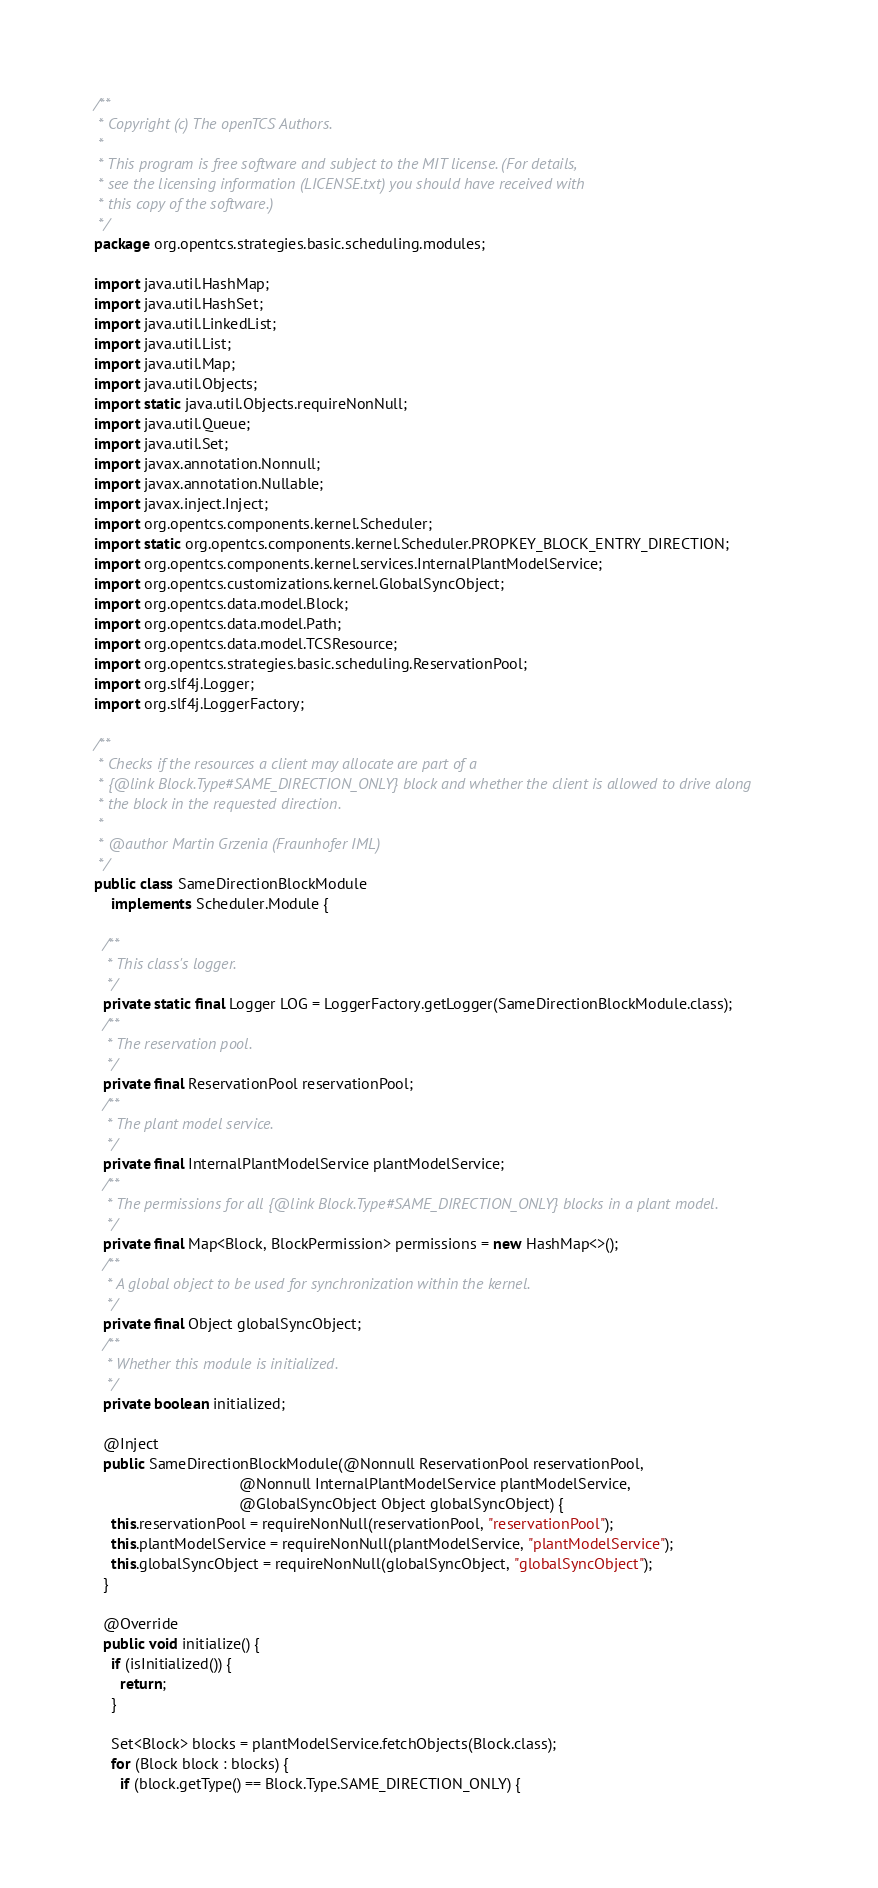Convert code to text. <code><loc_0><loc_0><loc_500><loc_500><_Java_>/**
 * Copyright (c) The openTCS Authors.
 *
 * This program is free software and subject to the MIT license. (For details,
 * see the licensing information (LICENSE.txt) you should have received with
 * this copy of the software.)
 */
package org.opentcs.strategies.basic.scheduling.modules;

import java.util.HashMap;
import java.util.HashSet;
import java.util.LinkedList;
import java.util.List;
import java.util.Map;
import java.util.Objects;
import static java.util.Objects.requireNonNull;
import java.util.Queue;
import java.util.Set;
import javax.annotation.Nonnull;
import javax.annotation.Nullable;
import javax.inject.Inject;
import org.opentcs.components.kernel.Scheduler;
import static org.opentcs.components.kernel.Scheduler.PROPKEY_BLOCK_ENTRY_DIRECTION;
import org.opentcs.components.kernel.services.InternalPlantModelService;
import org.opentcs.customizations.kernel.GlobalSyncObject;
import org.opentcs.data.model.Block;
import org.opentcs.data.model.Path;
import org.opentcs.data.model.TCSResource;
import org.opentcs.strategies.basic.scheduling.ReservationPool;
import org.slf4j.Logger;
import org.slf4j.LoggerFactory;

/**
 * Checks if the resources a client may allocate are part of a
 * {@link Block.Type#SAME_DIRECTION_ONLY} block and whether the client is allowed to drive along
 * the block in the requested direction.
 *
 * @author Martin Grzenia (Fraunhofer IML)
 */
public class SameDirectionBlockModule
    implements Scheduler.Module {

  /**
   * This class's logger.
   */
  private static final Logger LOG = LoggerFactory.getLogger(SameDirectionBlockModule.class);
  /**
   * The reservation pool.
   */
  private final ReservationPool reservationPool;
  /**
   * The plant model service.
   */
  private final InternalPlantModelService plantModelService;
  /**
   * The permissions for all {@link Block.Type#SAME_DIRECTION_ONLY} blocks in a plant model.
   */
  private final Map<Block, BlockPermission> permissions = new HashMap<>();
  /**
   * A global object to be used for synchronization within the kernel.
   */
  private final Object globalSyncObject;
  /**
   * Whether this module is initialized.
   */
  private boolean initialized;

  @Inject
  public SameDirectionBlockModule(@Nonnull ReservationPool reservationPool,
                                  @Nonnull InternalPlantModelService plantModelService,
                                  @GlobalSyncObject Object globalSyncObject) {
    this.reservationPool = requireNonNull(reservationPool, "reservationPool");
    this.plantModelService = requireNonNull(plantModelService, "plantModelService");
    this.globalSyncObject = requireNonNull(globalSyncObject, "globalSyncObject");
  }

  @Override
  public void initialize() {
    if (isInitialized()) {
      return;
    }

    Set<Block> blocks = plantModelService.fetchObjects(Block.class);
    for (Block block : blocks) {
      if (block.getType() == Block.Type.SAME_DIRECTION_ONLY) {</code> 